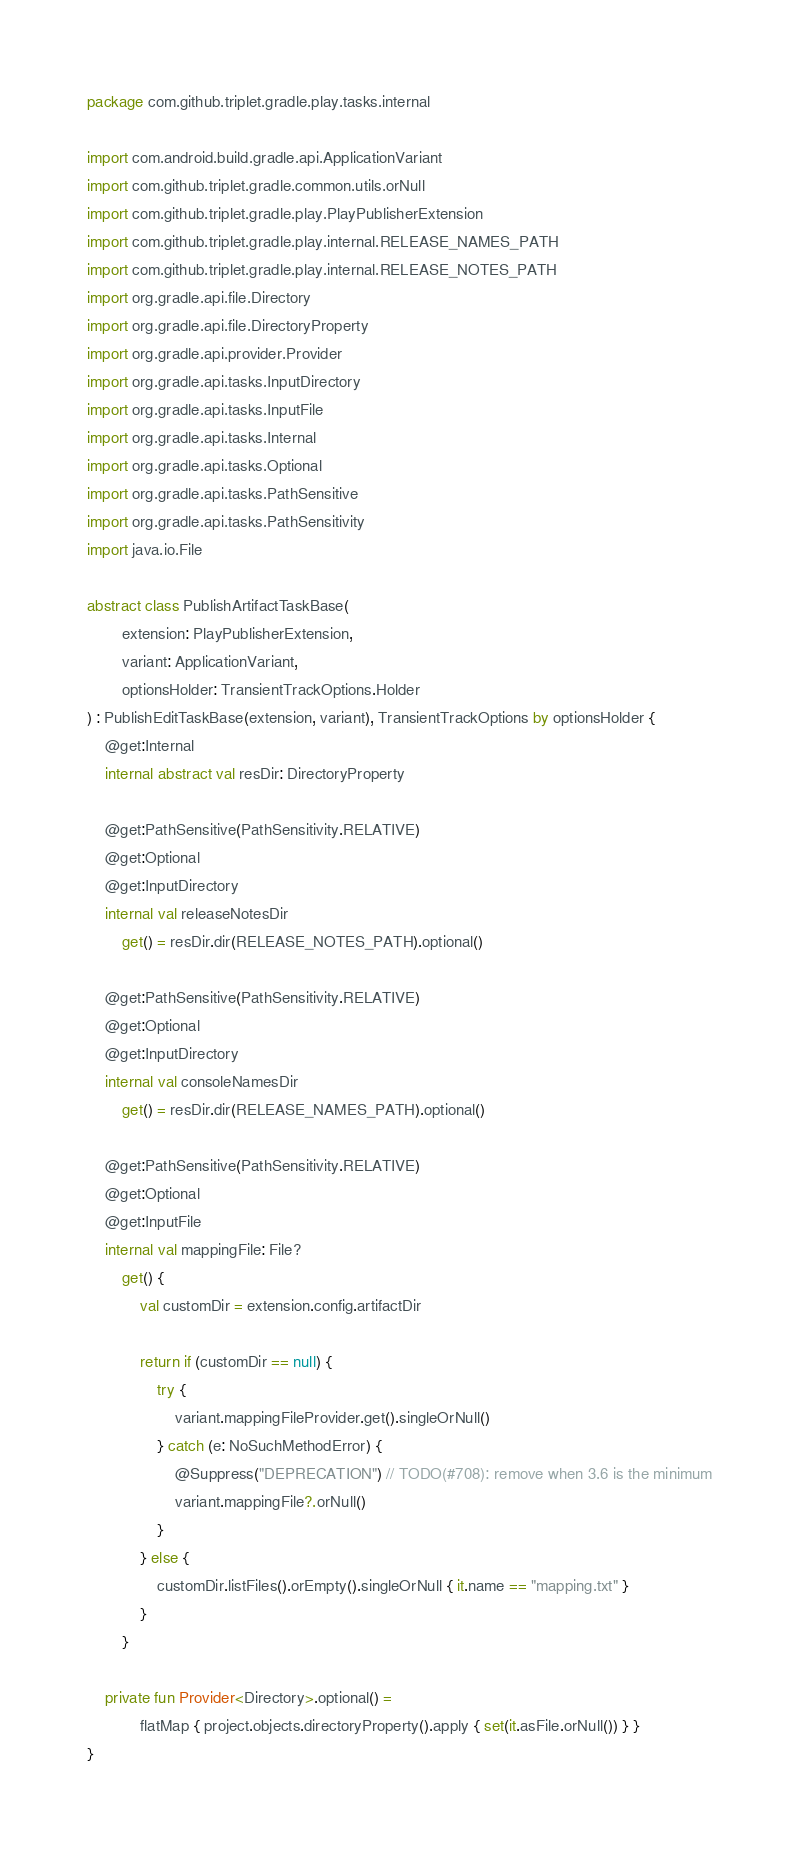Convert code to text. <code><loc_0><loc_0><loc_500><loc_500><_Kotlin_>package com.github.triplet.gradle.play.tasks.internal

import com.android.build.gradle.api.ApplicationVariant
import com.github.triplet.gradle.common.utils.orNull
import com.github.triplet.gradle.play.PlayPublisherExtension
import com.github.triplet.gradle.play.internal.RELEASE_NAMES_PATH
import com.github.triplet.gradle.play.internal.RELEASE_NOTES_PATH
import org.gradle.api.file.Directory
import org.gradle.api.file.DirectoryProperty
import org.gradle.api.provider.Provider
import org.gradle.api.tasks.InputDirectory
import org.gradle.api.tasks.InputFile
import org.gradle.api.tasks.Internal
import org.gradle.api.tasks.Optional
import org.gradle.api.tasks.PathSensitive
import org.gradle.api.tasks.PathSensitivity
import java.io.File

abstract class PublishArtifactTaskBase(
        extension: PlayPublisherExtension,
        variant: ApplicationVariant,
        optionsHolder: TransientTrackOptions.Holder
) : PublishEditTaskBase(extension, variant), TransientTrackOptions by optionsHolder {
    @get:Internal
    internal abstract val resDir: DirectoryProperty

    @get:PathSensitive(PathSensitivity.RELATIVE)
    @get:Optional
    @get:InputDirectory
    internal val releaseNotesDir
        get() = resDir.dir(RELEASE_NOTES_PATH).optional()

    @get:PathSensitive(PathSensitivity.RELATIVE)
    @get:Optional
    @get:InputDirectory
    internal val consoleNamesDir
        get() = resDir.dir(RELEASE_NAMES_PATH).optional()

    @get:PathSensitive(PathSensitivity.RELATIVE)
    @get:Optional
    @get:InputFile
    internal val mappingFile: File?
        get() {
            val customDir = extension.config.artifactDir

            return if (customDir == null) {
                try {
                    variant.mappingFileProvider.get().singleOrNull()
                } catch (e: NoSuchMethodError) {
                    @Suppress("DEPRECATION") // TODO(#708): remove when 3.6 is the minimum
                    variant.mappingFile?.orNull()
                }
            } else {
                customDir.listFiles().orEmpty().singleOrNull { it.name == "mapping.txt" }
            }
        }

    private fun Provider<Directory>.optional() =
            flatMap { project.objects.directoryProperty().apply { set(it.asFile.orNull()) } }
}
</code> 